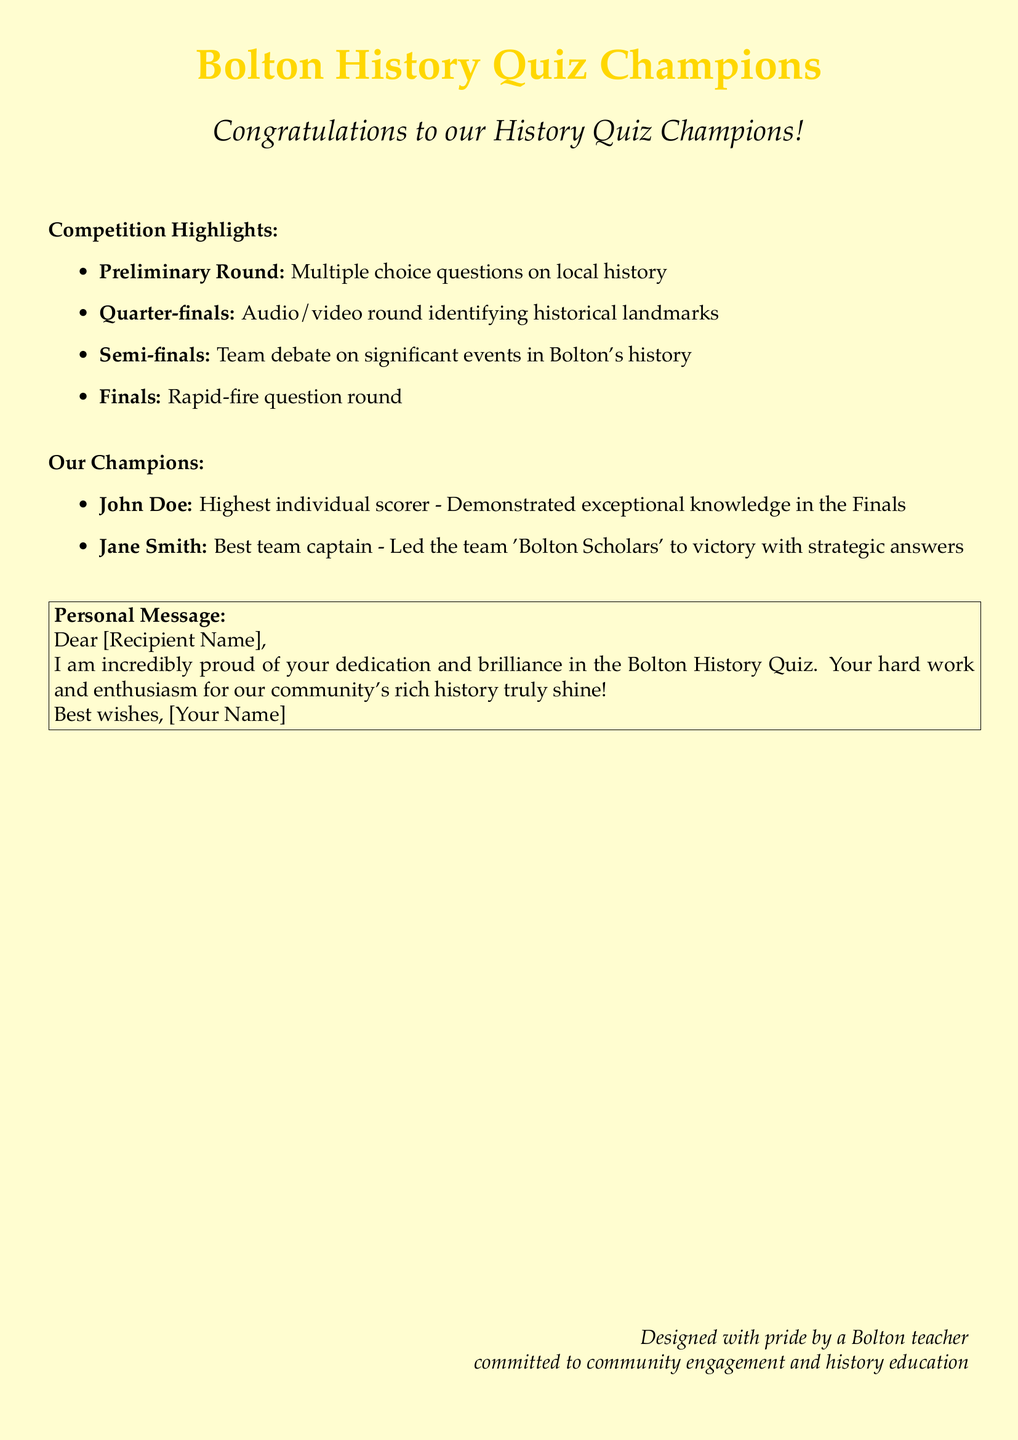What is the title of the card? The title of the card is prominently displayed at the top, celebrating the quiz champions.
Answer: Bolton History Quiz Champions Who was the highest individual scorer? This information specifies a particular person recognized for their achievement in the quiz competition.
Answer: John Doe What was the final round of the competition called? The document lists various rounds of the quiz competition, and the last one is referred to by a specific term.
Answer: Finals Who led the team 'Bolton Scholars'? This question focuses on identifying a key participant in the winning team during the quiz competition.
Answer: Jane Smith What type of round involved audio/video elements? The document details different rounds of the quiz, and this question refers to a specific round type that used media.
Answer: Quarter-finals What is included in the personal message section? The personal message section provides space for the teacher to express their thoughts, which is highlighted in the document.
Answer: Dear [Recipient Name], I am incredibly proud of your dedication and brilliance in the Bolton History Quiz How many rounds were mentioned in the competition highlights? This question focuses on the total number of rounds outlined in the competition highlights section.
Answer: Four What color is the medal represented in the design? The document describes a design feature and the associated color used prominently on the card.
Answer: Gold What is the focus of this greeting card? This question addresses the primary purpose of the card as conveyed in the content.
Answer: Community engagement and history education 